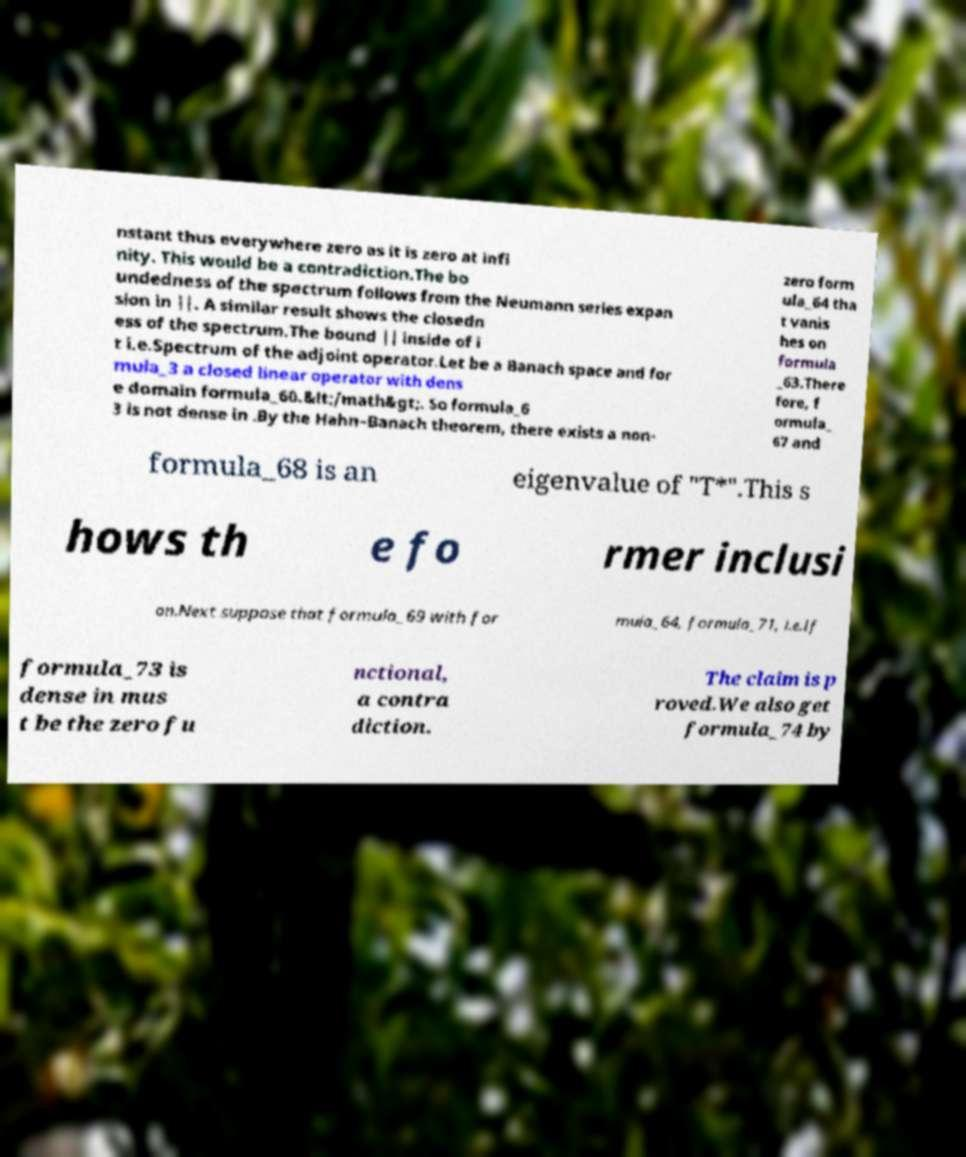Please read and relay the text visible in this image. What does it say? nstant thus everywhere zero as it is zero at infi nity. This would be a contradiction.The bo undedness of the spectrum follows from the Neumann series expan sion in ||. A similar result shows the closedn ess of the spectrum.The bound || inside of i t i.e.Spectrum of the adjoint operator.Let be a Banach space and for mula_3 a closed linear operator with dens e domain formula_60.&lt;/math&gt;. So formula_6 3 is not dense in .By the Hahn–Banach theorem, there exists a non- zero form ula_64 tha t vanis hes on formula _63.There fore, f ormula_ 67 and formula_68 is an eigenvalue of "T*".This s hows th e fo rmer inclusi on.Next suppose that formula_69 with for mula_64, formula_71, i.e.If formula_73 is dense in mus t be the zero fu nctional, a contra diction. The claim is p roved.We also get formula_74 by 